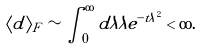<formula> <loc_0><loc_0><loc_500><loc_500>\langle d \rangle _ { F } \sim \int _ { 0 } ^ { \infty } d \lambda \lambda e ^ { - t \lambda ^ { 2 } } < \infty .</formula> 